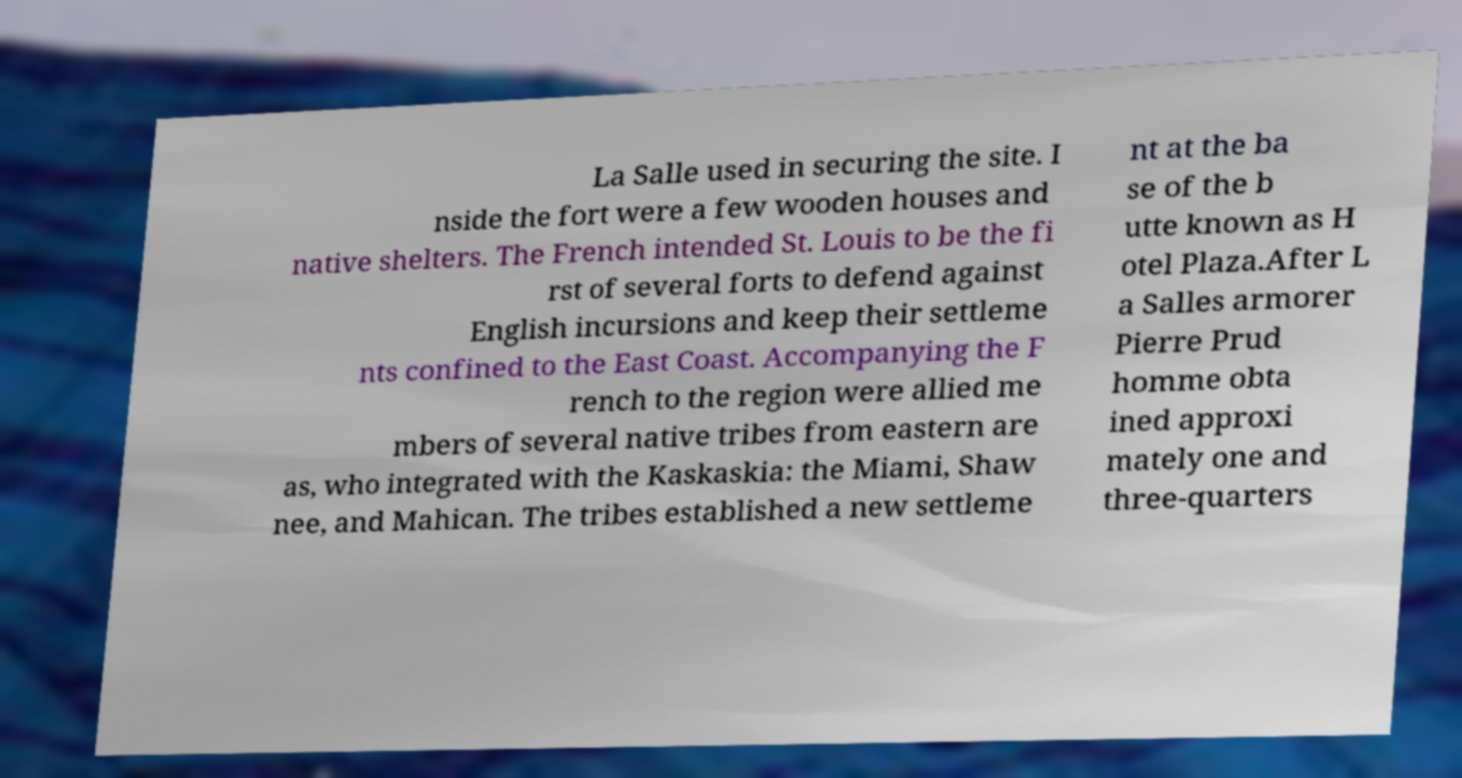I need the written content from this picture converted into text. Can you do that? La Salle used in securing the site. I nside the fort were a few wooden houses and native shelters. The French intended St. Louis to be the fi rst of several forts to defend against English incursions and keep their settleme nts confined to the East Coast. Accompanying the F rench to the region were allied me mbers of several native tribes from eastern are as, who integrated with the Kaskaskia: the Miami, Shaw nee, and Mahican. The tribes established a new settleme nt at the ba se of the b utte known as H otel Plaza.After L a Salles armorer Pierre Prud homme obta ined approxi mately one and three-quarters 